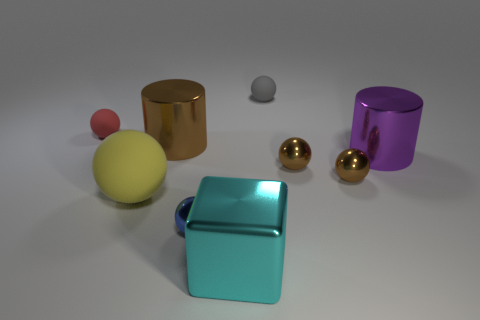Do the gray ball and the rubber sphere left of the yellow sphere have the same size?
Provide a succinct answer. Yes. What number of brown objects are tiny matte balls or matte things?
Provide a succinct answer. 0. What number of metallic objects are there?
Your answer should be compact. 6. There is a metallic cylinder behind the purple cylinder; what is its size?
Ensure brevity in your answer.  Large. Does the brown metallic cylinder have the same size as the blue metallic sphere?
Provide a succinct answer. No. What number of objects are shiny blocks or large cyan cubes to the right of the small red object?
Ensure brevity in your answer.  1. What is the material of the red sphere?
Keep it short and to the point. Rubber. Are there any other things of the same color as the big metallic block?
Make the answer very short. No. Is the shape of the purple metal object the same as the large brown object?
Provide a succinct answer. Yes. What is the size of the sphere behind the small matte object to the left of the tiny rubber sphere that is on the right side of the red sphere?
Make the answer very short. Small. 